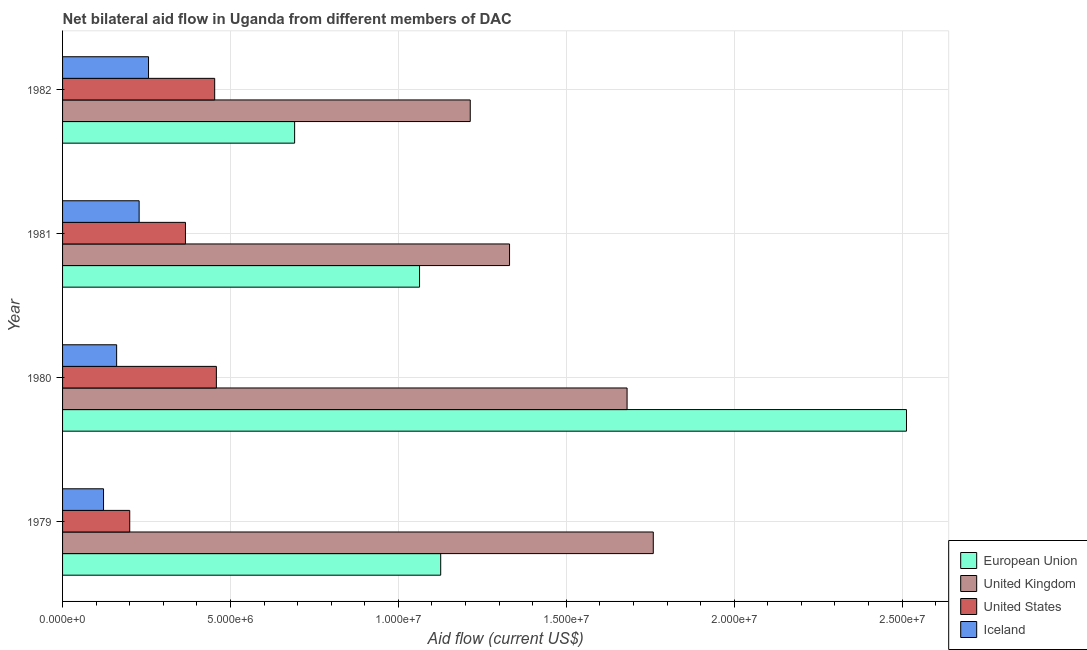How many groups of bars are there?
Your answer should be very brief. 4. How many bars are there on the 4th tick from the top?
Your answer should be compact. 4. In how many cases, is the number of bars for a given year not equal to the number of legend labels?
Offer a very short reply. 0. What is the amount of aid given by uk in 1981?
Offer a terse response. 1.33e+07. Across all years, what is the maximum amount of aid given by eu?
Provide a short and direct response. 2.51e+07. Across all years, what is the minimum amount of aid given by uk?
Your answer should be compact. 1.21e+07. In which year was the amount of aid given by uk minimum?
Make the answer very short. 1982. What is the total amount of aid given by uk in the graph?
Offer a very short reply. 5.98e+07. What is the difference between the amount of aid given by iceland in 1979 and that in 1981?
Give a very brief answer. -1.06e+06. What is the difference between the amount of aid given by eu in 1980 and the amount of aid given by uk in 1979?
Make the answer very short. 7.54e+06. What is the average amount of aid given by eu per year?
Offer a very short reply. 1.35e+07. In the year 1982, what is the difference between the amount of aid given by us and amount of aid given by iceland?
Provide a succinct answer. 1.97e+06. In how many years, is the amount of aid given by us greater than 11000000 US$?
Ensure brevity in your answer.  0. What is the difference between the highest and the lowest amount of aid given by us?
Your answer should be compact. 2.58e+06. Is it the case that in every year, the sum of the amount of aid given by iceland and amount of aid given by eu is greater than the sum of amount of aid given by us and amount of aid given by uk?
Provide a short and direct response. No. What does the 4th bar from the bottom in 1982 represents?
Provide a short and direct response. Iceland. Is it the case that in every year, the sum of the amount of aid given by eu and amount of aid given by uk is greater than the amount of aid given by us?
Your answer should be very brief. Yes. How many bars are there?
Ensure brevity in your answer.  16. Are the values on the major ticks of X-axis written in scientific E-notation?
Ensure brevity in your answer.  Yes. Does the graph contain any zero values?
Make the answer very short. No. Does the graph contain grids?
Provide a short and direct response. Yes. How many legend labels are there?
Ensure brevity in your answer.  4. What is the title of the graph?
Offer a terse response. Net bilateral aid flow in Uganda from different members of DAC. What is the label or title of the Y-axis?
Your answer should be very brief. Year. What is the Aid flow (current US$) of European Union in 1979?
Your answer should be very brief. 1.13e+07. What is the Aid flow (current US$) in United Kingdom in 1979?
Offer a very short reply. 1.76e+07. What is the Aid flow (current US$) of Iceland in 1979?
Your response must be concise. 1.22e+06. What is the Aid flow (current US$) of European Union in 1980?
Offer a very short reply. 2.51e+07. What is the Aid flow (current US$) in United Kingdom in 1980?
Offer a very short reply. 1.68e+07. What is the Aid flow (current US$) of United States in 1980?
Your answer should be very brief. 4.58e+06. What is the Aid flow (current US$) of Iceland in 1980?
Ensure brevity in your answer.  1.61e+06. What is the Aid flow (current US$) of European Union in 1981?
Provide a short and direct response. 1.06e+07. What is the Aid flow (current US$) of United Kingdom in 1981?
Provide a short and direct response. 1.33e+07. What is the Aid flow (current US$) of United States in 1981?
Ensure brevity in your answer.  3.66e+06. What is the Aid flow (current US$) in Iceland in 1981?
Your answer should be compact. 2.28e+06. What is the Aid flow (current US$) of European Union in 1982?
Your response must be concise. 6.91e+06. What is the Aid flow (current US$) in United Kingdom in 1982?
Keep it short and to the point. 1.21e+07. What is the Aid flow (current US$) in United States in 1982?
Make the answer very short. 4.53e+06. What is the Aid flow (current US$) in Iceland in 1982?
Provide a succinct answer. 2.56e+06. Across all years, what is the maximum Aid flow (current US$) of European Union?
Offer a terse response. 2.51e+07. Across all years, what is the maximum Aid flow (current US$) in United Kingdom?
Keep it short and to the point. 1.76e+07. Across all years, what is the maximum Aid flow (current US$) in United States?
Your response must be concise. 4.58e+06. Across all years, what is the maximum Aid flow (current US$) of Iceland?
Ensure brevity in your answer.  2.56e+06. Across all years, what is the minimum Aid flow (current US$) in European Union?
Provide a succinct answer. 6.91e+06. Across all years, what is the minimum Aid flow (current US$) of United Kingdom?
Your response must be concise. 1.21e+07. Across all years, what is the minimum Aid flow (current US$) of Iceland?
Provide a short and direct response. 1.22e+06. What is the total Aid flow (current US$) of European Union in the graph?
Give a very brief answer. 5.39e+07. What is the total Aid flow (current US$) in United Kingdom in the graph?
Keep it short and to the point. 5.98e+07. What is the total Aid flow (current US$) of United States in the graph?
Your response must be concise. 1.48e+07. What is the total Aid flow (current US$) of Iceland in the graph?
Offer a very short reply. 7.67e+06. What is the difference between the Aid flow (current US$) of European Union in 1979 and that in 1980?
Offer a terse response. -1.39e+07. What is the difference between the Aid flow (current US$) in United Kingdom in 1979 and that in 1980?
Provide a succinct answer. 7.80e+05. What is the difference between the Aid flow (current US$) of United States in 1979 and that in 1980?
Your response must be concise. -2.58e+06. What is the difference between the Aid flow (current US$) of Iceland in 1979 and that in 1980?
Offer a terse response. -3.90e+05. What is the difference between the Aid flow (current US$) in European Union in 1979 and that in 1981?
Offer a very short reply. 6.30e+05. What is the difference between the Aid flow (current US$) in United Kingdom in 1979 and that in 1981?
Offer a terse response. 4.28e+06. What is the difference between the Aid flow (current US$) in United States in 1979 and that in 1981?
Provide a short and direct response. -1.66e+06. What is the difference between the Aid flow (current US$) in Iceland in 1979 and that in 1981?
Ensure brevity in your answer.  -1.06e+06. What is the difference between the Aid flow (current US$) of European Union in 1979 and that in 1982?
Your answer should be compact. 4.35e+06. What is the difference between the Aid flow (current US$) of United Kingdom in 1979 and that in 1982?
Ensure brevity in your answer.  5.45e+06. What is the difference between the Aid flow (current US$) of United States in 1979 and that in 1982?
Keep it short and to the point. -2.53e+06. What is the difference between the Aid flow (current US$) of Iceland in 1979 and that in 1982?
Your response must be concise. -1.34e+06. What is the difference between the Aid flow (current US$) in European Union in 1980 and that in 1981?
Keep it short and to the point. 1.45e+07. What is the difference between the Aid flow (current US$) in United Kingdom in 1980 and that in 1981?
Provide a succinct answer. 3.50e+06. What is the difference between the Aid flow (current US$) of United States in 1980 and that in 1981?
Provide a short and direct response. 9.20e+05. What is the difference between the Aid flow (current US$) in Iceland in 1980 and that in 1981?
Your response must be concise. -6.70e+05. What is the difference between the Aid flow (current US$) in European Union in 1980 and that in 1982?
Offer a very short reply. 1.82e+07. What is the difference between the Aid flow (current US$) of United Kingdom in 1980 and that in 1982?
Provide a short and direct response. 4.67e+06. What is the difference between the Aid flow (current US$) in United States in 1980 and that in 1982?
Provide a succinct answer. 5.00e+04. What is the difference between the Aid flow (current US$) of Iceland in 1980 and that in 1982?
Provide a short and direct response. -9.50e+05. What is the difference between the Aid flow (current US$) of European Union in 1981 and that in 1982?
Provide a succinct answer. 3.72e+06. What is the difference between the Aid flow (current US$) of United Kingdom in 1981 and that in 1982?
Provide a short and direct response. 1.17e+06. What is the difference between the Aid flow (current US$) of United States in 1981 and that in 1982?
Give a very brief answer. -8.70e+05. What is the difference between the Aid flow (current US$) in Iceland in 1981 and that in 1982?
Your answer should be compact. -2.80e+05. What is the difference between the Aid flow (current US$) in European Union in 1979 and the Aid flow (current US$) in United Kingdom in 1980?
Keep it short and to the point. -5.55e+06. What is the difference between the Aid flow (current US$) of European Union in 1979 and the Aid flow (current US$) of United States in 1980?
Provide a succinct answer. 6.68e+06. What is the difference between the Aid flow (current US$) in European Union in 1979 and the Aid flow (current US$) in Iceland in 1980?
Ensure brevity in your answer.  9.65e+06. What is the difference between the Aid flow (current US$) of United Kingdom in 1979 and the Aid flow (current US$) of United States in 1980?
Give a very brief answer. 1.30e+07. What is the difference between the Aid flow (current US$) in United Kingdom in 1979 and the Aid flow (current US$) in Iceland in 1980?
Your answer should be compact. 1.60e+07. What is the difference between the Aid flow (current US$) in United States in 1979 and the Aid flow (current US$) in Iceland in 1980?
Provide a short and direct response. 3.90e+05. What is the difference between the Aid flow (current US$) in European Union in 1979 and the Aid flow (current US$) in United Kingdom in 1981?
Offer a terse response. -2.05e+06. What is the difference between the Aid flow (current US$) of European Union in 1979 and the Aid flow (current US$) of United States in 1981?
Your answer should be compact. 7.60e+06. What is the difference between the Aid flow (current US$) in European Union in 1979 and the Aid flow (current US$) in Iceland in 1981?
Offer a very short reply. 8.98e+06. What is the difference between the Aid flow (current US$) of United Kingdom in 1979 and the Aid flow (current US$) of United States in 1981?
Your answer should be very brief. 1.39e+07. What is the difference between the Aid flow (current US$) of United Kingdom in 1979 and the Aid flow (current US$) of Iceland in 1981?
Your answer should be very brief. 1.53e+07. What is the difference between the Aid flow (current US$) of United States in 1979 and the Aid flow (current US$) of Iceland in 1981?
Your answer should be very brief. -2.80e+05. What is the difference between the Aid flow (current US$) in European Union in 1979 and the Aid flow (current US$) in United Kingdom in 1982?
Make the answer very short. -8.80e+05. What is the difference between the Aid flow (current US$) of European Union in 1979 and the Aid flow (current US$) of United States in 1982?
Keep it short and to the point. 6.73e+06. What is the difference between the Aid flow (current US$) of European Union in 1979 and the Aid flow (current US$) of Iceland in 1982?
Provide a short and direct response. 8.70e+06. What is the difference between the Aid flow (current US$) of United Kingdom in 1979 and the Aid flow (current US$) of United States in 1982?
Ensure brevity in your answer.  1.31e+07. What is the difference between the Aid flow (current US$) in United Kingdom in 1979 and the Aid flow (current US$) in Iceland in 1982?
Your response must be concise. 1.50e+07. What is the difference between the Aid flow (current US$) of United States in 1979 and the Aid flow (current US$) of Iceland in 1982?
Provide a succinct answer. -5.60e+05. What is the difference between the Aid flow (current US$) in European Union in 1980 and the Aid flow (current US$) in United Kingdom in 1981?
Keep it short and to the point. 1.18e+07. What is the difference between the Aid flow (current US$) in European Union in 1980 and the Aid flow (current US$) in United States in 1981?
Your answer should be compact. 2.15e+07. What is the difference between the Aid flow (current US$) in European Union in 1980 and the Aid flow (current US$) in Iceland in 1981?
Your answer should be compact. 2.28e+07. What is the difference between the Aid flow (current US$) in United Kingdom in 1980 and the Aid flow (current US$) in United States in 1981?
Your answer should be compact. 1.32e+07. What is the difference between the Aid flow (current US$) in United Kingdom in 1980 and the Aid flow (current US$) in Iceland in 1981?
Offer a terse response. 1.45e+07. What is the difference between the Aid flow (current US$) of United States in 1980 and the Aid flow (current US$) of Iceland in 1981?
Keep it short and to the point. 2.30e+06. What is the difference between the Aid flow (current US$) in European Union in 1980 and the Aid flow (current US$) in United Kingdom in 1982?
Offer a very short reply. 1.30e+07. What is the difference between the Aid flow (current US$) of European Union in 1980 and the Aid flow (current US$) of United States in 1982?
Make the answer very short. 2.06e+07. What is the difference between the Aid flow (current US$) of European Union in 1980 and the Aid flow (current US$) of Iceland in 1982?
Offer a very short reply. 2.26e+07. What is the difference between the Aid flow (current US$) in United Kingdom in 1980 and the Aid flow (current US$) in United States in 1982?
Give a very brief answer. 1.23e+07. What is the difference between the Aid flow (current US$) of United Kingdom in 1980 and the Aid flow (current US$) of Iceland in 1982?
Your answer should be compact. 1.42e+07. What is the difference between the Aid flow (current US$) of United States in 1980 and the Aid flow (current US$) of Iceland in 1982?
Keep it short and to the point. 2.02e+06. What is the difference between the Aid flow (current US$) of European Union in 1981 and the Aid flow (current US$) of United Kingdom in 1982?
Offer a terse response. -1.51e+06. What is the difference between the Aid flow (current US$) in European Union in 1981 and the Aid flow (current US$) in United States in 1982?
Offer a very short reply. 6.10e+06. What is the difference between the Aid flow (current US$) in European Union in 1981 and the Aid flow (current US$) in Iceland in 1982?
Ensure brevity in your answer.  8.07e+06. What is the difference between the Aid flow (current US$) in United Kingdom in 1981 and the Aid flow (current US$) in United States in 1982?
Provide a succinct answer. 8.78e+06. What is the difference between the Aid flow (current US$) of United Kingdom in 1981 and the Aid flow (current US$) of Iceland in 1982?
Your answer should be very brief. 1.08e+07. What is the difference between the Aid flow (current US$) of United States in 1981 and the Aid flow (current US$) of Iceland in 1982?
Offer a terse response. 1.10e+06. What is the average Aid flow (current US$) in European Union per year?
Ensure brevity in your answer.  1.35e+07. What is the average Aid flow (current US$) of United Kingdom per year?
Give a very brief answer. 1.50e+07. What is the average Aid flow (current US$) of United States per year?
Offer a very short reply. 3.69e+06. What is the average Aid flow (current US$) in Iceland per year?
Your answer should be very brief. 1.92e+06. In the year 1979, what is the difference between the Aid flow (current US$) in European Union and Aid flow (current US$) in United Kingdom?
Make the answer very short. -6.33e+06. In the year 1979, what is the difference between the Aid flow (current US$) of European Union and Aid flow (current US$) of United States?
Provide a succinct answer. 9.26e+06. In the year 1979, what is the difference between the Aid flow (current US$) in European Union and Aid flow (current US$) in Iceland?
Offer a terse response. 1.00e+07. In the year 1979, what is the difference between the Aid flow (current US$) in United Kingdom and Aid flow (current US$) in United States?
Offer a terse response. 1.56e+07. In the year 1979, what is the difference between the Aid flow (current US$) of United Kingdom and Aid flow (current US$) of Iceland?
Give a very brief answer. 1.64e+07. In the year 1979, what is the difference between the Aid flow (current US$) of United States and Aid flow (current US$) of Iceland?
Your response must be concise. 7.80e+05. In the year 1980, what is the difference between the Aid flow (current US$) of European Union and Aid flow (current US$) of United Kingdom?
Your response must be concise. 8.32e+06. In the year 1980, what is the difference between the Aid flow (current US$) of European Union and Aid flow (current US$) of United States?
Provide a short and direct response. 2.06e+07. In the year 1980, what is the difference between the Aid flow (current US$) in European Union and Aid flow (current US$) in Iceland?
Your answer should be compact. 2.35e+07. In the year 1980, what is the difference between the Aid flow (current US$) of United Kingdom and Aid flow (current US$) of United States?
Provide a short and direct response. 1.22e+07. In the year 1980, what is the difference between the Aid flow (current US$) of United Kingdom and Aid flow (current US$) of Iceland?
Your answer should be very brief. 1.52e+07. In the year 1980, what is the difference between the Aid flow (current US$) of United States and Aid flow (current US$) of Iceland?
Ensure brevity in your answer.  2.97e+06. In the year 1981, what is the difference between the Aid flow (current US$) of European Union and Aid flow (current US$) of United Kingdom?
Provide a short and direct response. -2.68e+06. In the year 1981, what is the difference between the Aid flow (current US$) of European Union and Aid flow (current US$) of United States?
Offer a terse response. 6.97e+06. In the year 1981, what is the difference between the Aid flow (current US$) of European Union and Aid flow (current US$) of Iceland?
Offer a terse response. 8.35e+06. In the year 1981, what is the difference between the Aid flow (current US$) in United Kingdom and Aid flow (current US$) in United States?
Your answer should be very brief. 9.65e+06. In the year 1981, what is the difference between the Aid flow (current US$) of United Kingdom and Aid flow (current US$) of Iceland?
Ensure brevity in your answer.  1.10e+07. In the year 1981, what is the difference between the Aid flow (current US$) in United States and Aid flow (current US$) in Iceland?
Offer a very short reply. 1.38e+06. In the year 1982, what is the difference between the Aid flow (current US$) of European Union and Aid flow (current US$) of United Kingdom?
Your answer should be compact. -5.23e+06. In the year 1982, what is the difference between the Aid flow (current US$) of European Union and Aid flow (current US$) of United States?
Give a very brief answer. 2.38e+06. In the year 1982, what is the difference between the Aid flow (current US$) in European Union and Aid flow (current US$) in Iceland?
Your answer should be compact. 4.35e+06. In the year 1982, what is the difference between the Aid flow (current US$) in United Kingdom and Aid flow (current US$) in United States?
Your answer should be compact. 7.61e+06. In the year 1982, what is the difference between the Aid flow (current US$) of United Kingdom and Aid flow (current US$) of Iceland?
Offer a very short reply. 9.58e+06. In the year 1982, what is the difference between the Aid flow (current US$) in United States and Aid flow (current US$) in Iceland?
Offer a terse response. 1.97e+06. What is the ratio of the Aid flow (current US$) of European Union in 1979 to that in 1980?
Your response must be concise. 0.45. What is the ratio of the Aid flow (current US$) of United Kingdom in 1979 to that in 1980?
Provide a short and direct response. 1.05. What is the ratio of the Aid flow (current US$) in United States in 1979 to that in 1980?
Keep it short and to the point. 0.44. What is the ratio of the Aid flow (current US$) of Iceland in 1979 to that in 1980?
Offer a very short reply. 0.76. What is the ratio of the Aid flow (current US$) of European Union in 1979 to that in 1981?
Provide a short and direct response. 1.06. What is the ratio of the Aid flow (current US$) in United Kingdom in 1979 to that in 1981?
Give a very brief answer. 1.32. What is the ratio of the Aid flow (current US$) of United States in 1979 to that in 1981?
Your answer should be very brief. 0.55. What is the ratio of the Aid flow (current US$) in Iceland in 1979 to that in 1981?
Provide a succinct answer. 0.54. What is the ratio of the Aid flow (current US$) in European Union in 1979 to that in 1982?
Keep it short and to the point. 1.63. What is the ratio of the Aid flow (current US$) of United Kingdom in 1979 to that in 1982?
Make the answer very short. 1.45. What is the ratio of the Aid flow (current US$) in United States in 1979 to that in 1982?
Provide a succinct answer. 0.44. What is the ratio of the Aid flow (current US$) of Iceland in 1979 to that in 1982?
Give a very brief answer. 0.48. What is the ratio of the Aid flow (current US$) in European Union in 1980 to that in 1981?
Your response must be concise. 2.36. What is the ratio of the Aid flow (current US$) of United Kingdom in 1980 to that in 1981?
Your answer should be very brief. 1.26. What is the ratio of the Aid flow (current US$) of United States in 1980 to that in 1981?
Your answer should be compact. 1.25. What is the ratio of the Aid flow (current US$) of Iceland in 1980 to that in 1981?
Offer a very short reply. 0.71. What is the ratio of the Aid flow (current US$) in European Union in 1980 to that in 1982?
Your response must be concise. 3.64. What is the ratio of the Aid flow (current US$) in United Kingdom in 1980 to that in 1982?
Ensure brevity in your answer.  1.38. What is the ratio of the Aid flow (current US$) in Iceland in 1980 to that in 1982?
Provide a succinct answer. 0.63. What is the ratio of the Aid flow (current US$) of European Union in 1981 to that in 1982?
Keep it short and to the point. 1.54. What is the ratio of the Aid flow (current US$) of United Kingdom in 1981 to that in 1982?
Ensure brevity in your answer.  1.1. What is the ratio of the Aid flow (current US$) of United States in 1981 to that in 1982?
Your response must be concise. 0.81. What is the ratio of the Aid flow (current US$) of Iceland in 1981 to that in 1982?
Your response must be concise. 0.89. What is the difference between the highest and the second highest Aid flow (current US$) in European Union?
Keep it short and to the point. 1.39e+07. What is the difference between the highest and the second highest Aid flow (current US$) of United Kingdom?
Provide a short and direct response. 7.80e+05. What is the difference between the highest and the lowest Aid flow (current US$) of European Union?
Your answer should be compact. 1.82e+07. What is the difference between the highest and the lowest Aid flow (current US$) in United Kingdom?
Offer a terse response. 5.45e+06. What is the difference between the highest and the lowest Aid flow (current US$) of United States?
Offer a terse response. 2.58e+06. What is the difference between the highest and the lowest Aid flow (current US$) in Iceland?
Provide a succinct answer. 1.34e+06. 